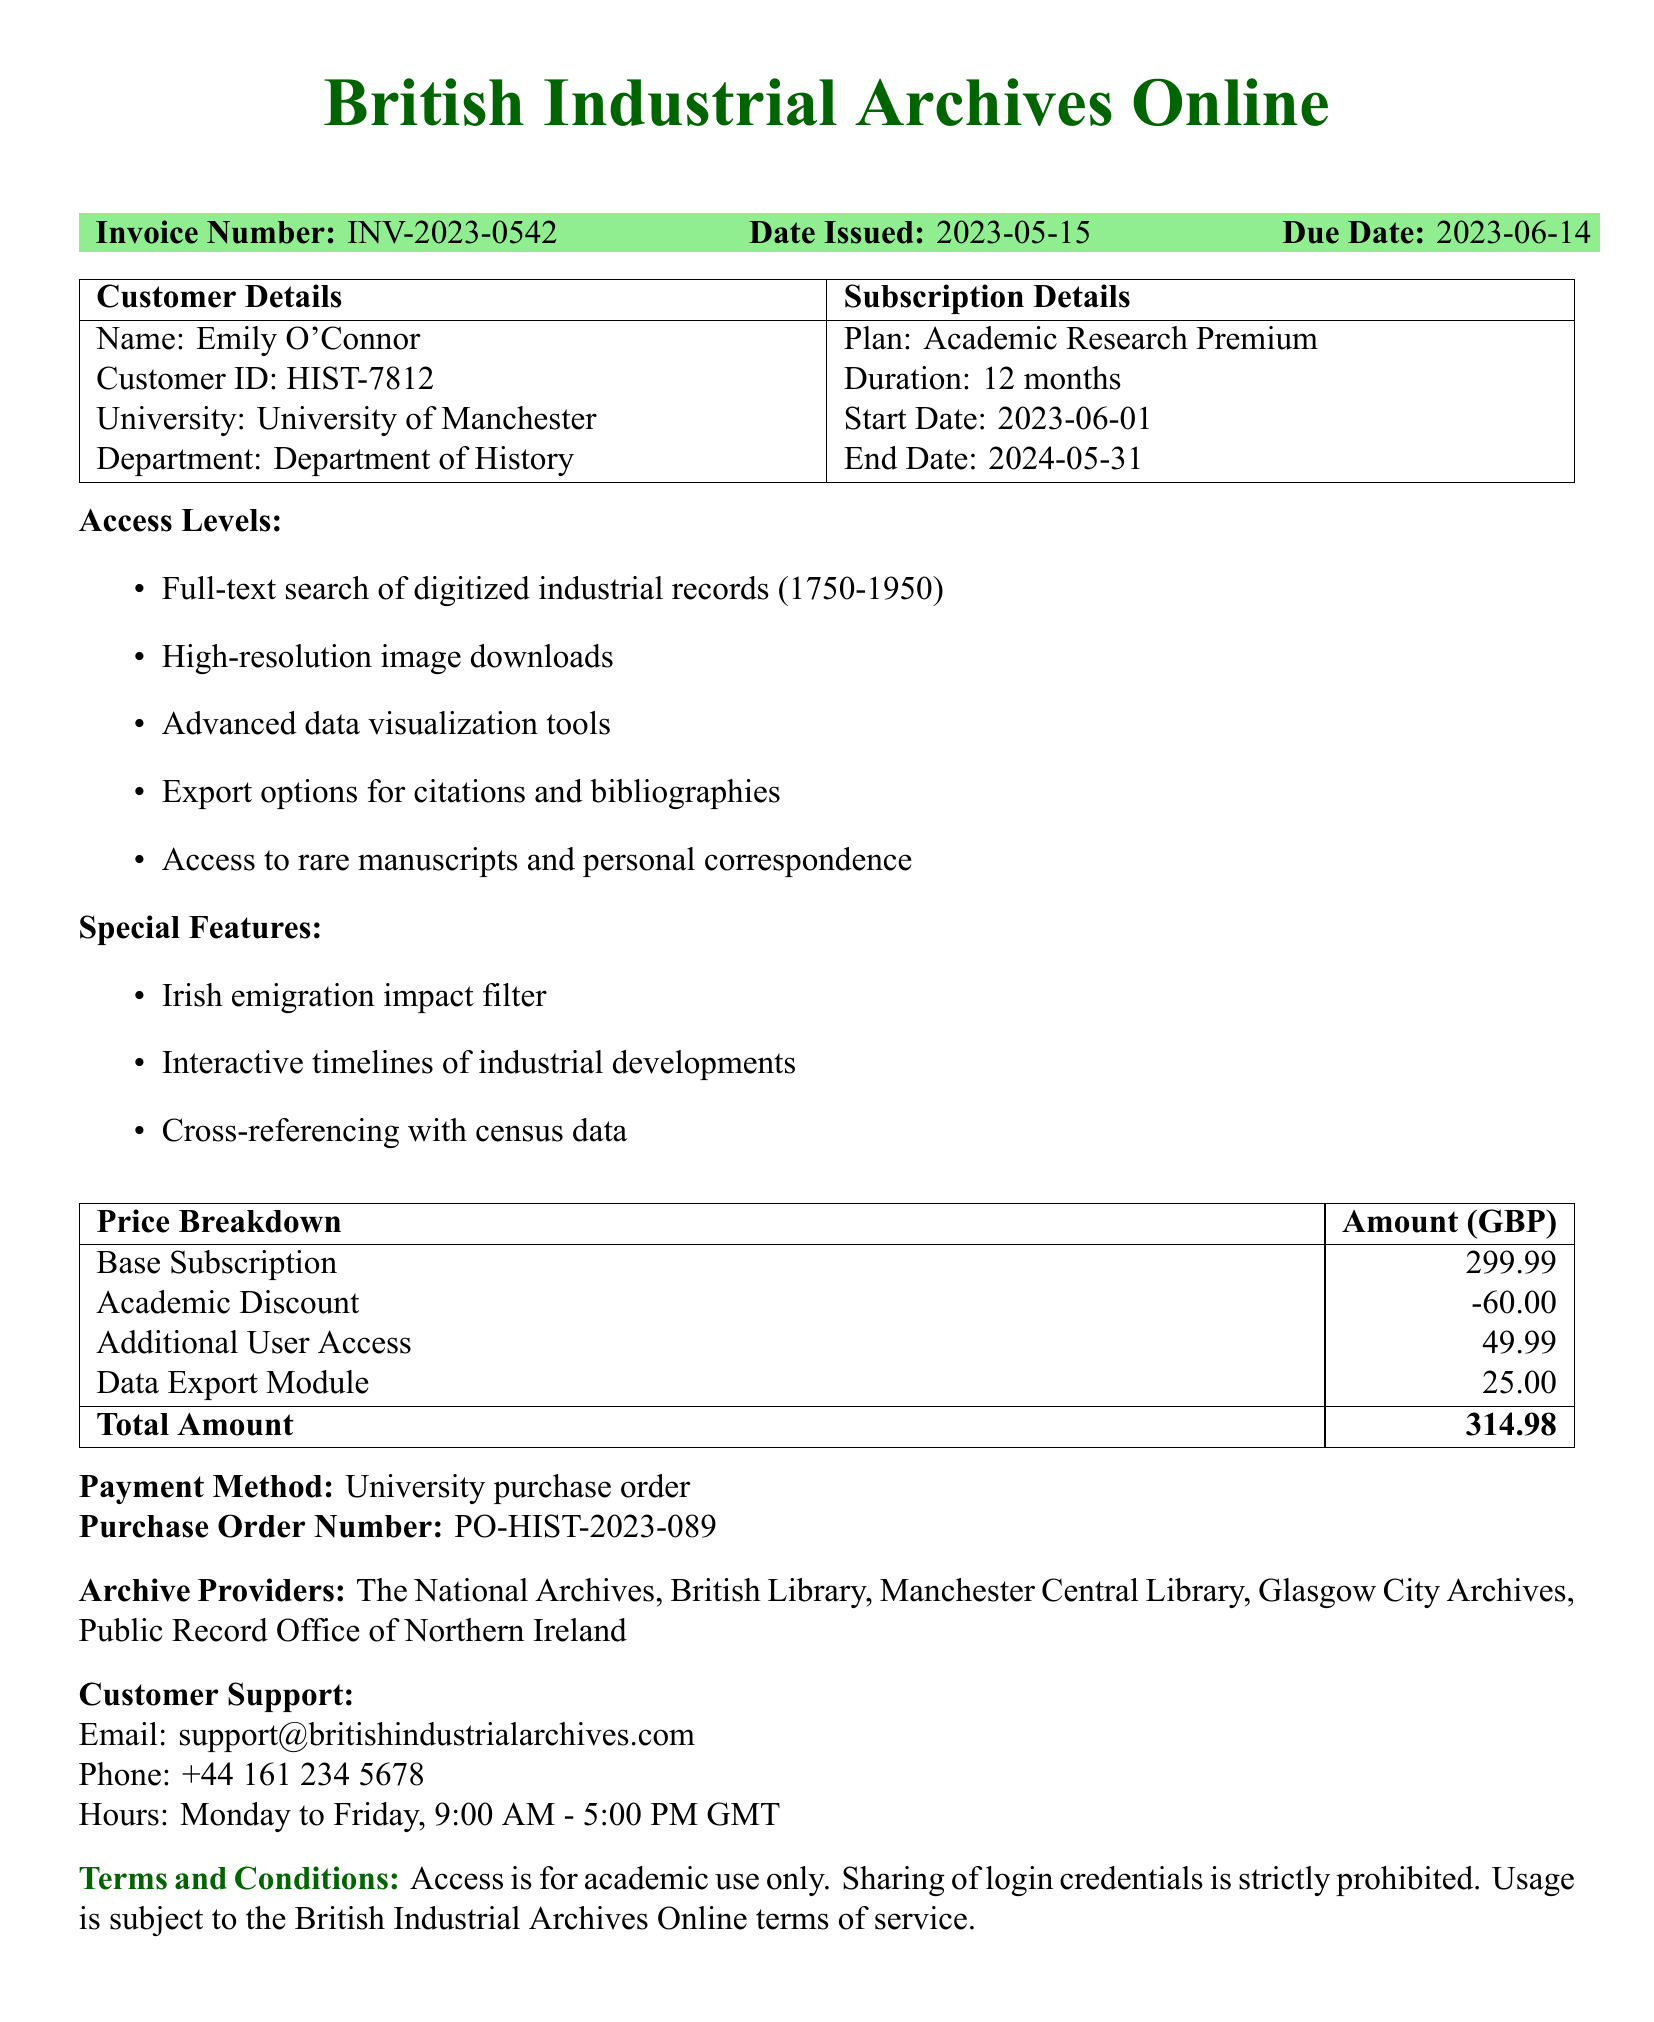What is the invoice number? The invoice number is clearly stated in the document for identification purposes.
Answer: INV-2023-0542 What is the due date of the invoice? The due date is listed to inform the customer when payment is expected.
Answer: 2023-06-14 What subscription plan was purchased? The specific subscription plan is mentioned in the subscription details section of the document.
Answer: Academic Research Premium How long is the subscription duration? The subscription duration is specified alongside the plan information.
Answer: 12 months What is the total amount due? The total amount due is presented in the price breakdown section of the document.
Answer: 314.98 Which special feature relates to Irish emigration? The document includes special features that enhance the research experience related to Irish emigration.
Answer: Irish emigration impact filter Which university is the customer affiliated with? The customer's affiliation is noted under the customer details for identification.
Answer: University of Manchester What payment method was used? The payment method is provided to indicate how the transaction will be processed.
Answer: University purchase order 